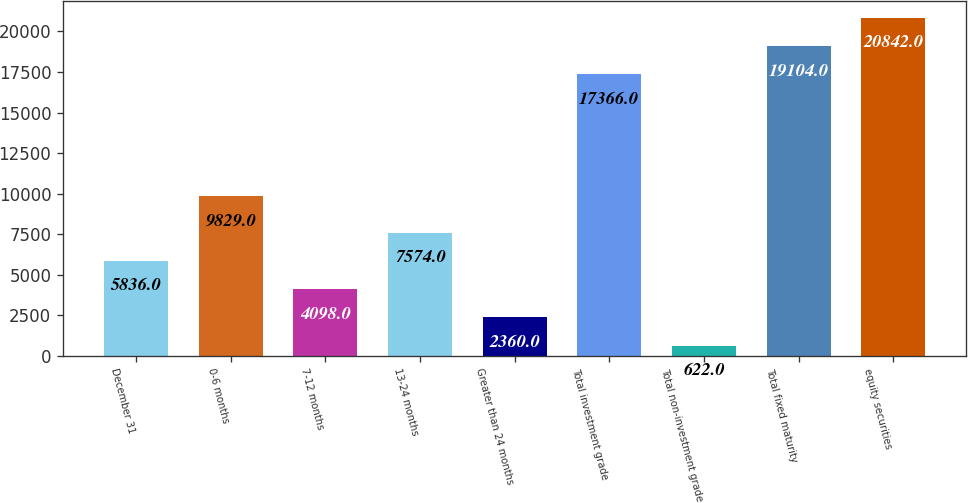<chart> <loc_0><loc_0><loc_500><loc_500><bar_chart><fcel>December 31<fcel>0-6 months<fcel>7-12 months<fcel>13-24 months<fcel>Greater than 24 months<fcel>Total investment grade<fcel>Total non-investment grade<fcel>Total fixed maturity<fcel>equity securities<nl><fcel>5836<fcel>9829<fcel>4098<fcel>7574<fcel>2360<fcel>17366<fcel>622<fcel>19104<fcel>20842<nl></chart> 